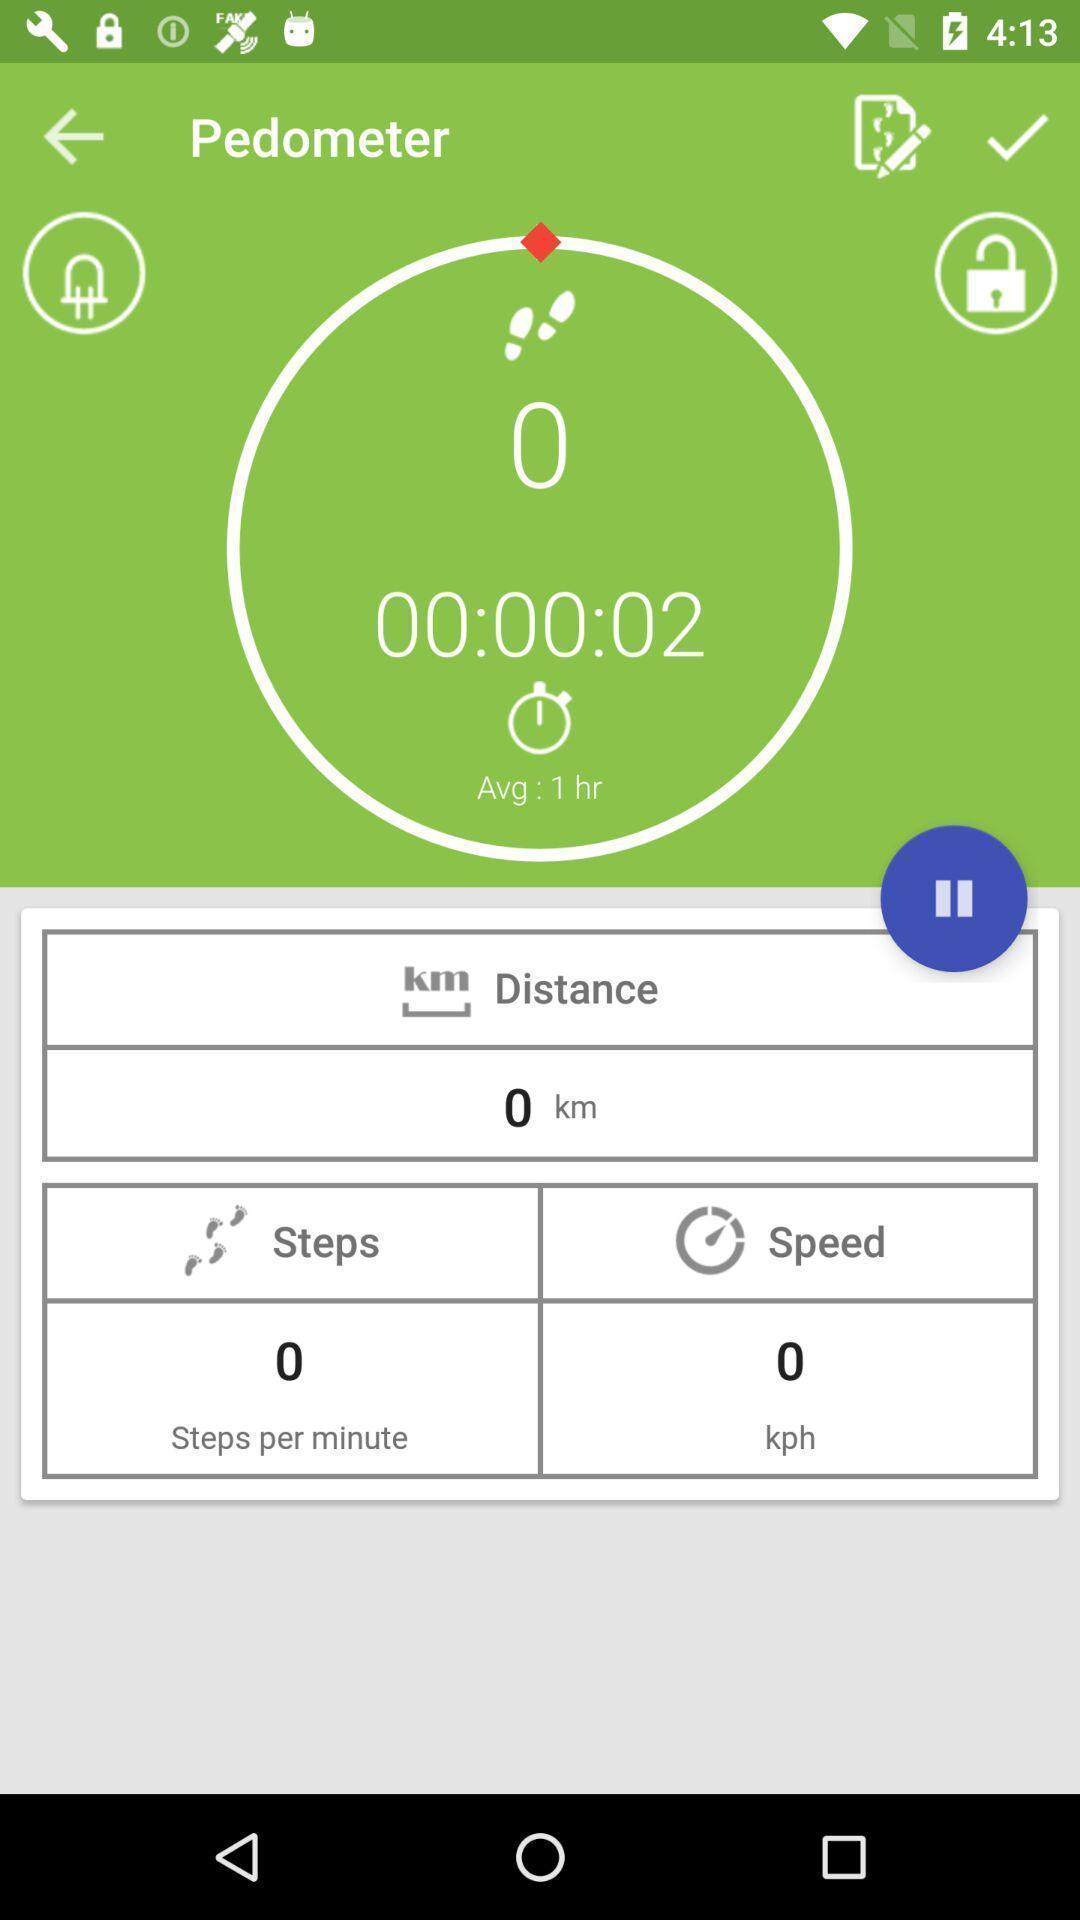Tell me what you see in this picture. Step tracking page of a tracking app. 